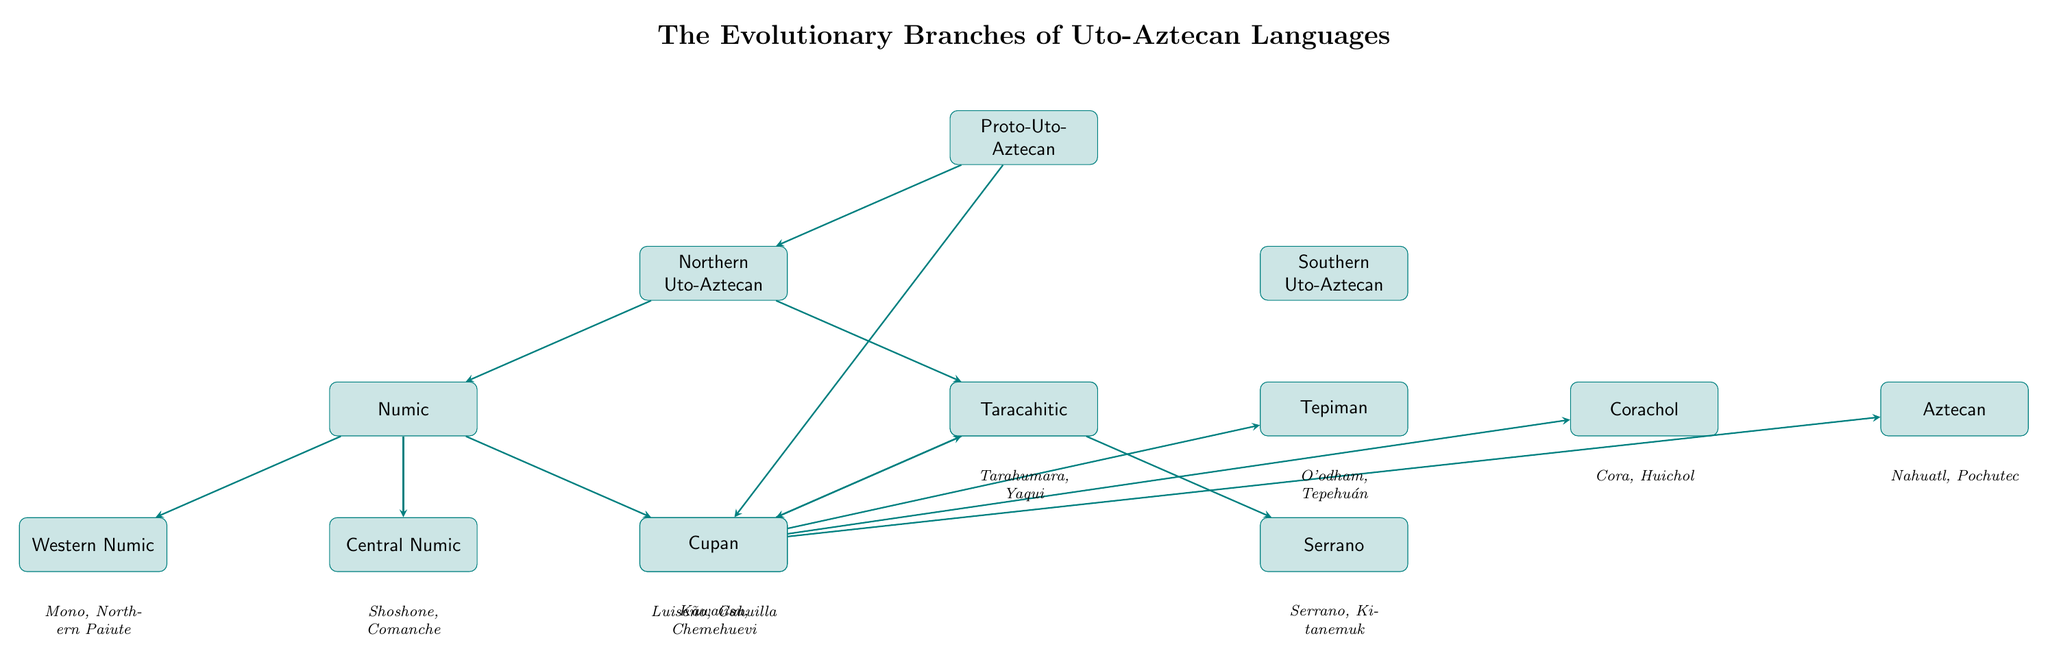What is the root node of the diagram? The root node of the diagram is "Proto-Uto-Aztecan," which represents the ancestral language from which all Uto-Aztecan languages evolved.
Answer: Proto-Uto-Aztecan How many primary branches are there under Proto-Uto-Aztecan? There are two primary branches under Proto-Uto-Aztecan: "Northern Uto-Aztecan" and "Southern Uto-Aztecan." This can be observed directly from the two arrows leading from the root node to these two branches.
Answer: 2 What are the examples given for Central Numic? The examples listed for Central Numic are "Shoshone" and "Comanche," which are noted directly beneath the Central Numic node in the diagram.
Answer: Shoshone, Comanche Which language family includes the languages "Nahuatl" and "Pochutec"? The language family that includes "Nahuatl" and "Pochutec" is "Aztecan," as seen directly from the corresponding node in the diagram that lists these examples.
Answer: Aztecan How many children does the Takic branch have? The Takic branch has two children, which are "Cupan" and "Serrano." This is confirmed by examining the connections of the Takic node in the diagram.
Answer: 2 What is the relationship between Numic and Southern Uto-Aztecan? Numic is a sub-branch of Northern Uto-Aztecan, while Southern Uto-Aztecan is a separate primary branch. There is no direct connection between Numic and Southern Uto-Aztecan as they are on different branches.
Answer: Separate branches What is the difference in examples given between the Western Numic and Taracahitic branches? Western Numic includes "Mono" and "Northern Paiute," while Taracahitic includes "Tarahumara" and "Yaqui." This illustrates the diversity within the language families, each with distinct languages.
Answer: Different examples Which branch of the Uto-Aztecan languages has the language "Tepehuán"? The language "Tepehuán" belongs to the "Tepiman" branch of Southern Uto-Aztecan, as indicated in the diagram where it is listed under this specific node.
Answer: Tepiman What is the total number of languages (examples) listed in the diagram? There are a total of eight languages listed in the diagram, comprising two from each of the branches (with some branches having one or two examples), specifically counting all examples from the nodes on level 3.
Answer: 8 What does the arrow direction signify in this diagram? The arrow direction signifies the evolutionary relationships and connections from the ancestral language to its descendant languages, indicating a hierarchical structure of language evolution in the Uto-Aztecan family.
Answer: Evolutionary relationships 